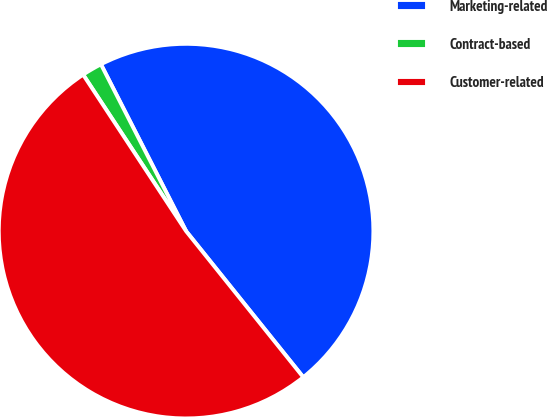Convert chart to OTSL. <chart><loc_0><loc_0><loc_500><loc_500><pie_chart><fcel>Marketing-related<fcel>Contract-based<fcel>Customer-related<nl><fcel>46.75%<fcel>1.75%<fcel>51.5%<nl></chart> 